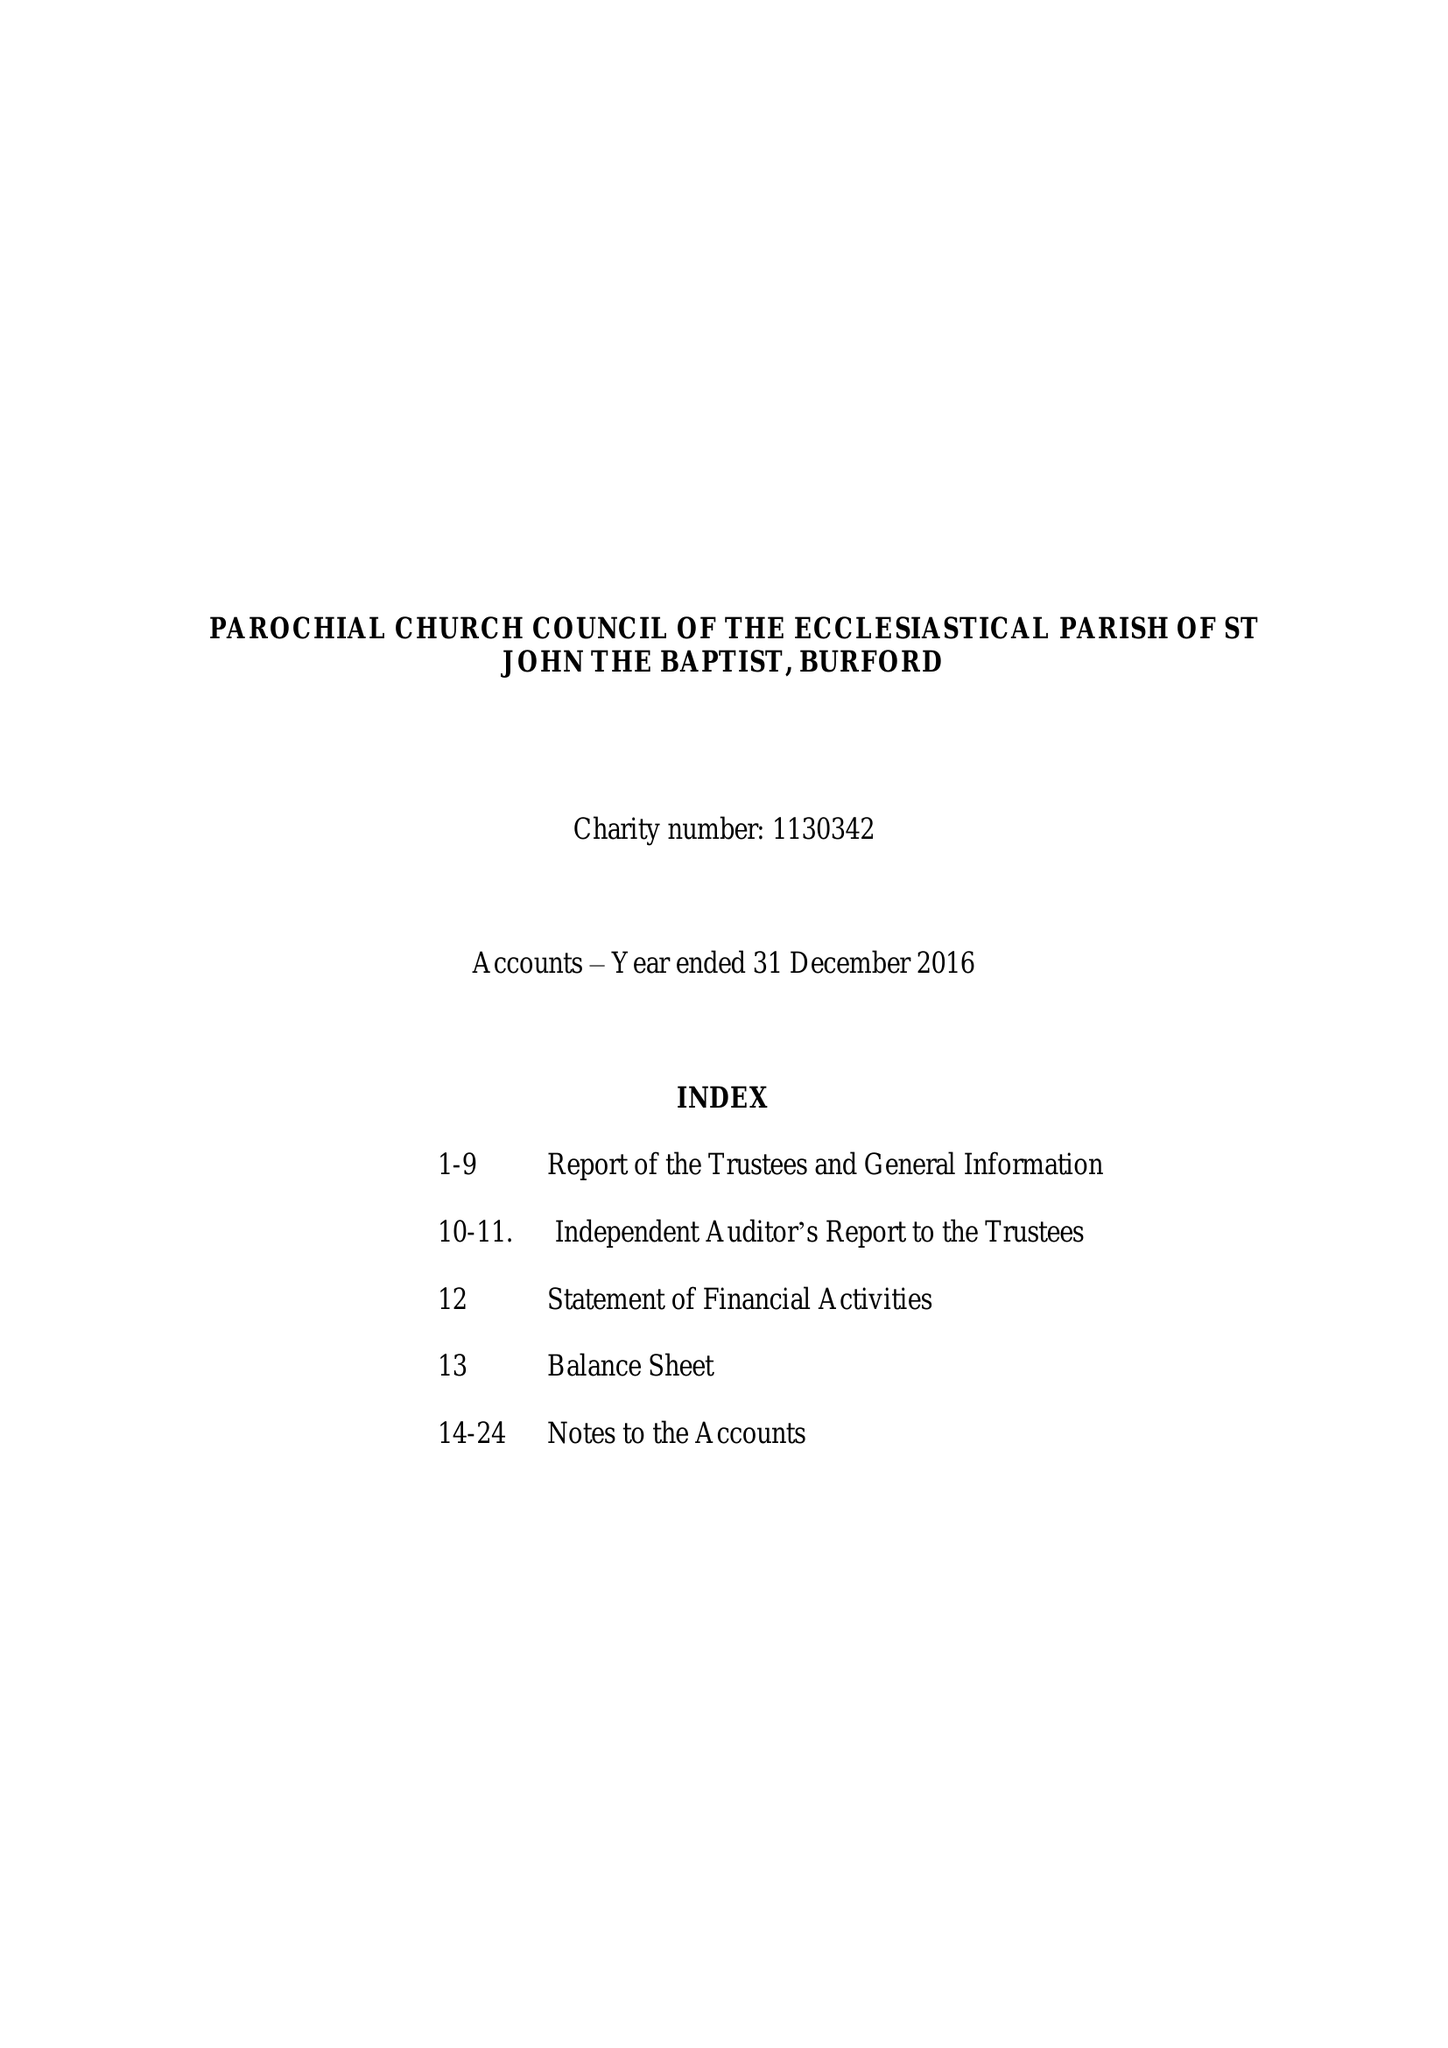What is the value for the charity_name?
Answer the question using a single word or phrase. The Parochial Church Council Of The Ecclesiastical Parish Of St John The Baptist, Burford 